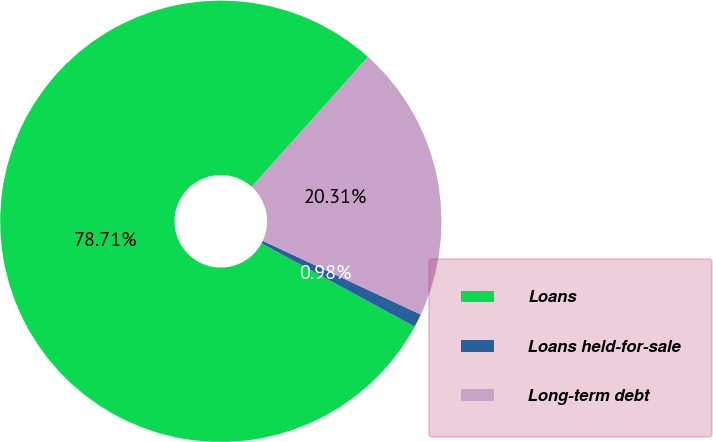<chart> <loc_0><loc_0><loc_500><loc_500><pie_chart><fcel>Loans<fcel>Loans held-for-sale<fcel>Long-term debt<nl><fcel>78.71%<fcel>0.98%<fcel>20.31%<nl></chart> 